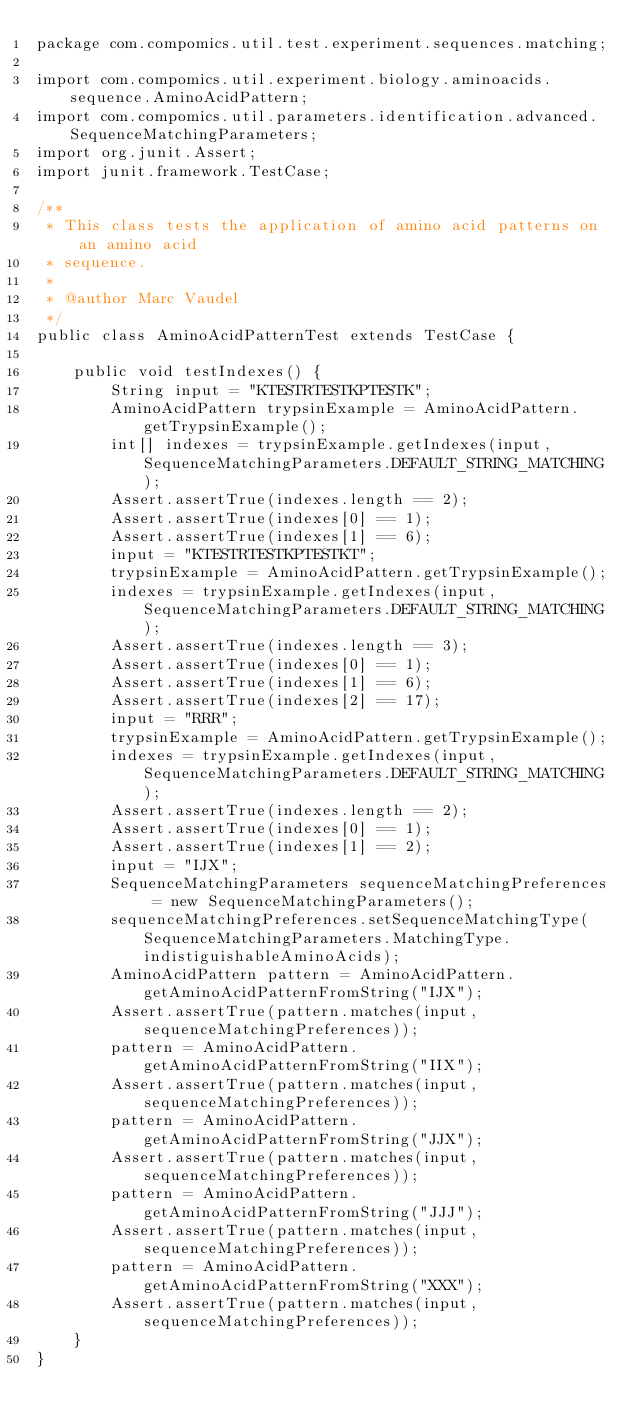<code> <loc_0><loc_0><loc_500><loc_500><_Java_>package com.compomics.util.test.experiment.sequences.matching;

import com.compomics.util.experiment.biology.aminoacids.sequence.AminoAcidPattern;
import com.compomics.util.parameters.identification.advanced.SequenceMatchingParameters;
import org.junit.Assert;
import junit.framework.TestCase;

/**
 * This class tests the application of amino acid patterns on an amino acid
 * sequence.
 *
 * @author Marc Vaudel
 */
public class AminoAcidPatternTest extends TestCase {

    public void testIndexes() {
        String input = "KTESTRTESTKPTESTK";
        AminoAcidPattern trypsinExample = AminoAcidPattern.getTrypsinExample();
        int[] indexes = trypsinExample.getIndexes(input, SequenceMatchingParameters.DEFAULT_STRING_MATCHING);
        Assert.assertTrue(indexes.length == 2);
        Assert.assertTrue(indexes[0] == 1);
        Assert.assertTrue(indexes[1] == 6);
        input = "KTESTRTESTKPTESTKT";
        trypsinExample = AminoAcidPattern.getTrypsinExample();
        indexes = trypsinExample.getIndexes(input, SequenceMatchingParameters.DEFAULT_STRING_MATCHING);
        Assert.assertTrue(indexes.length == 3);
        Assert.assertTrue(indexes[0] == 1);
        Assert.assertTrue(indexes[1] == 6);
        Assert.assertTrue(indexes[2] == 17);
        input = "RRR";
        trypsinExample = AminoAcidPattern.getTrypsinExample();
        indexes = trypsinExample.getIndexes(input, SequenceMatchingParameters.DEFAULT_STRING_MATCHING);
        Assert.assertTrue(indexes.length == 2);
        Assert.assertTrue(indexes[0] == 1);
        Assert.assertTrue(indexes[1] == 2);
        input = "IJX";
        SequenceMatchingParameters sequenceMatchingPreferences = new SequenceMatchingParameters();
        sequenceMatchingPreferences.setSequenceMatchingType(SequenceMatchingParameters.MatchingType.indistiguishableAminoAcids);
        AminoAcidPattern pattern = AminoAcidPattern.getAminoAcidPatternFromString("IJX");
        Assert.assertTrue(pattern.matches(input, sequenceMatchingPreferences));
        pattern = AminoAcidPattern.getAminoAcidPatternFromString("IIX");
        Assert.assertTrue(pattern.matches(input, sequenceMatchingPreferences));
        pattern = AminoAcidPattern.getAminoAcidPatternFromString("JJX");
        Assert.assertTrue(pattern.matches(input, sequenceMatchingPreferences));
        pattern = AminoAcidPattern.getAminoAcidPatternFromString("JJJ");
        Assert.assertTrue(pattern.matches(input, sequenceMatchingPreferences));
        pattern = AminoAcidPattern.getAminoAcidPatternFromString("XXX");
        Assert.assertTrue(pattern.matches(input, sequenceMatchingPreferences));
    }
}
</code> 